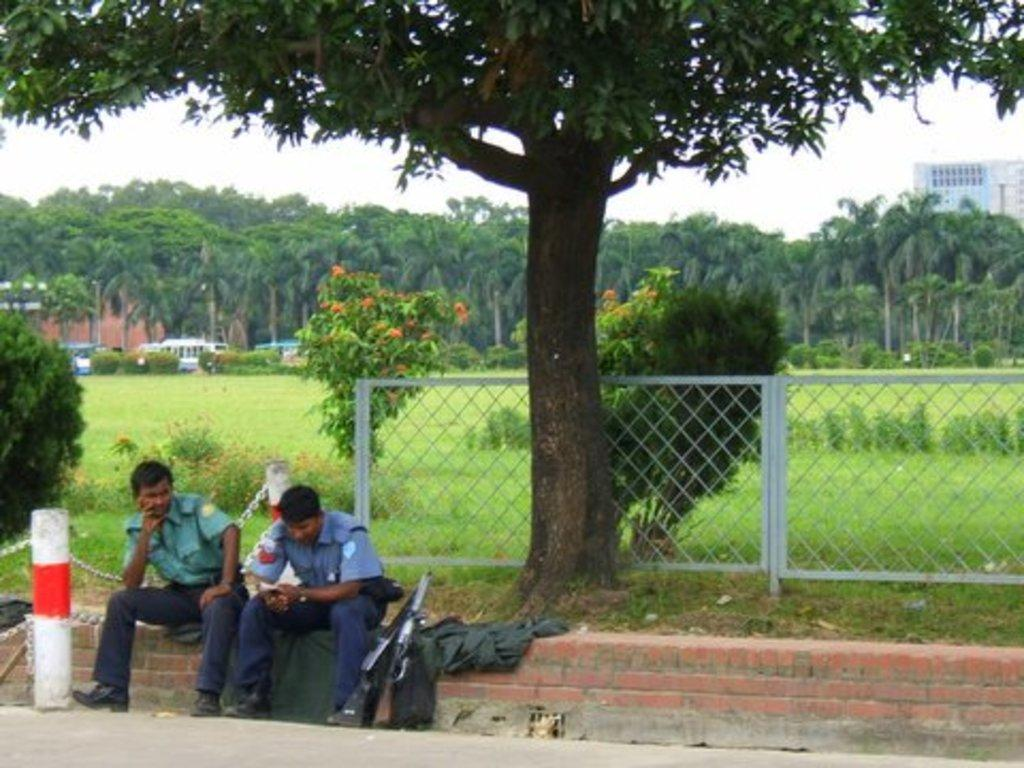What are the people in the image doing? The people in the image are sitting on the path. What else can be seen on the path in the image? There are objects on the path in the image. What structures are present in the image? There are poles, buildings, and trees in the image. What types of transportation are visible in the image? There are vehicles in the image. What is visible in the sky in the image? The sky is visible in the image. Can you tell me how many ants are crawling on the people in the image? There are no ants present in the image; it only shows people sitting on the path. What advice would the uncle in the image give to the people sitting on the path? There is no uncle present in the image, so it is not possible to determine what advice he might give. 